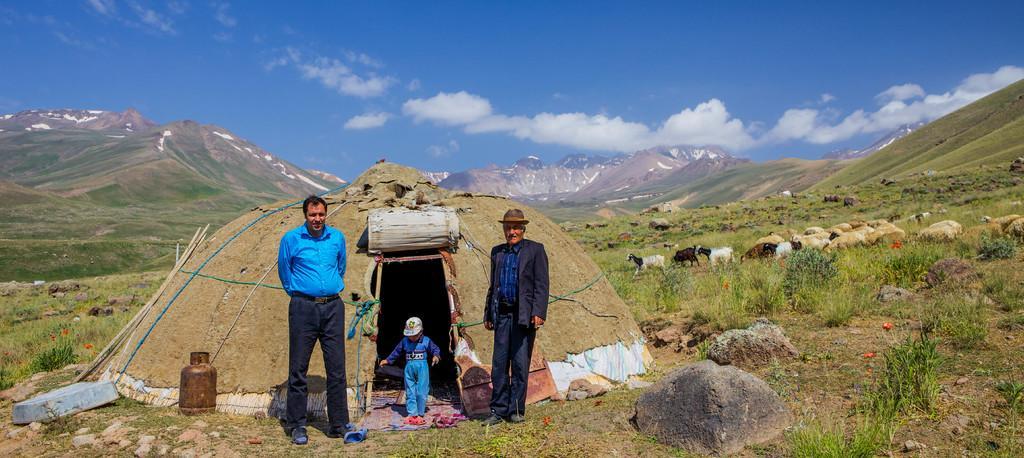Could you give a brief overview of what you see in this image? In this picture, we see the man in blue shirt and the man in a black blazer and hat are standing. In between them, the boy in blue shirt and white cap is standing. Behind them, we see a tent. Beside that, we see a cylinder and rocks. At the bottom of the picture, we see the grass. On the right side, we see sheep and goats are grazing in the field. There are hills in the background. At the top of the picture, we see the clouds and the sky. 